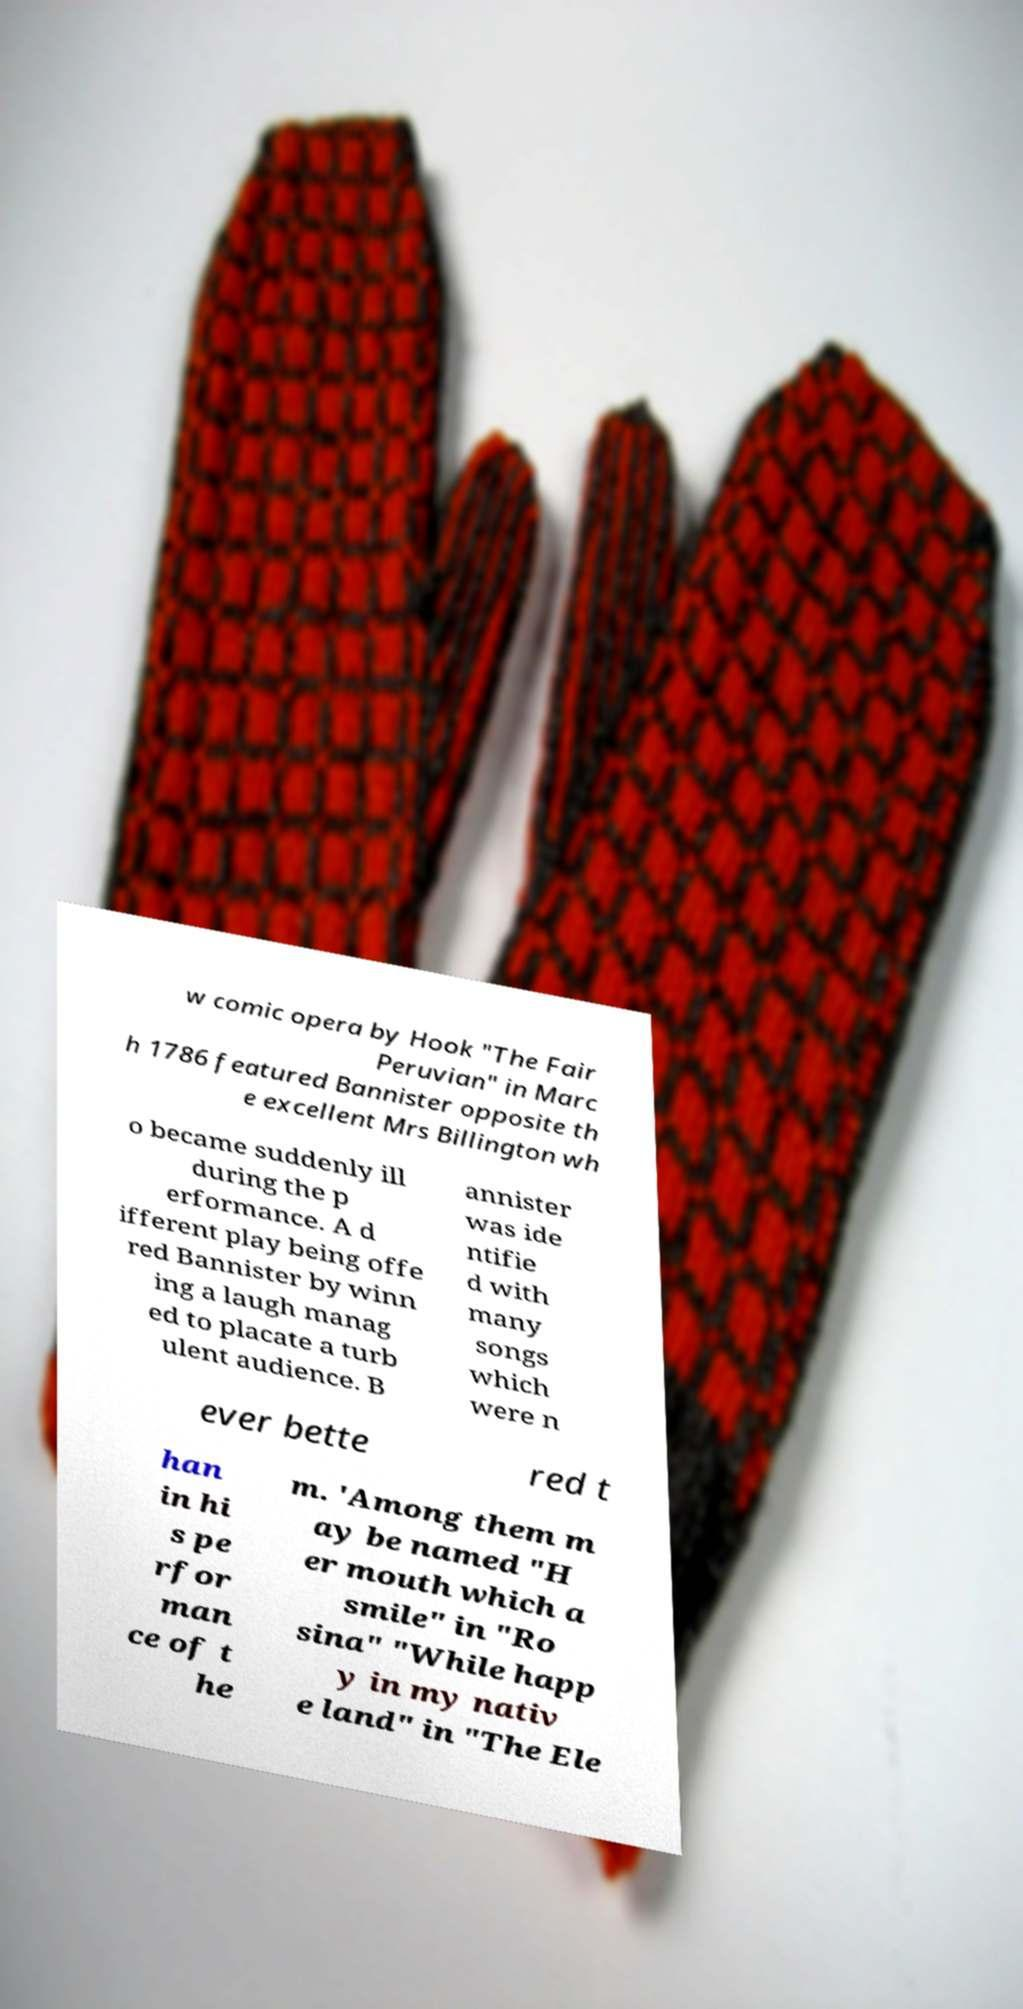Please read and relay the text visible in this image. What does it say? w comic opera by Hook "The Fair Peruvian" in Marc h 1786 featured Bannister opposite th e excellent Mrs Billington wh o became suddenly ill during the p erformance. A d ifferent play being offe red Bannister by winn ing a laugh manag ed to placate a turb ulent audience. B annister was ide ntifie d with many songs which were n ever bette red t han in hi s pe rfor man ce of t he m. 'Among them m ay be named "H er mouth which a smile" in "Ro sina" "While happ y in my nativ e land" in "The Ele 